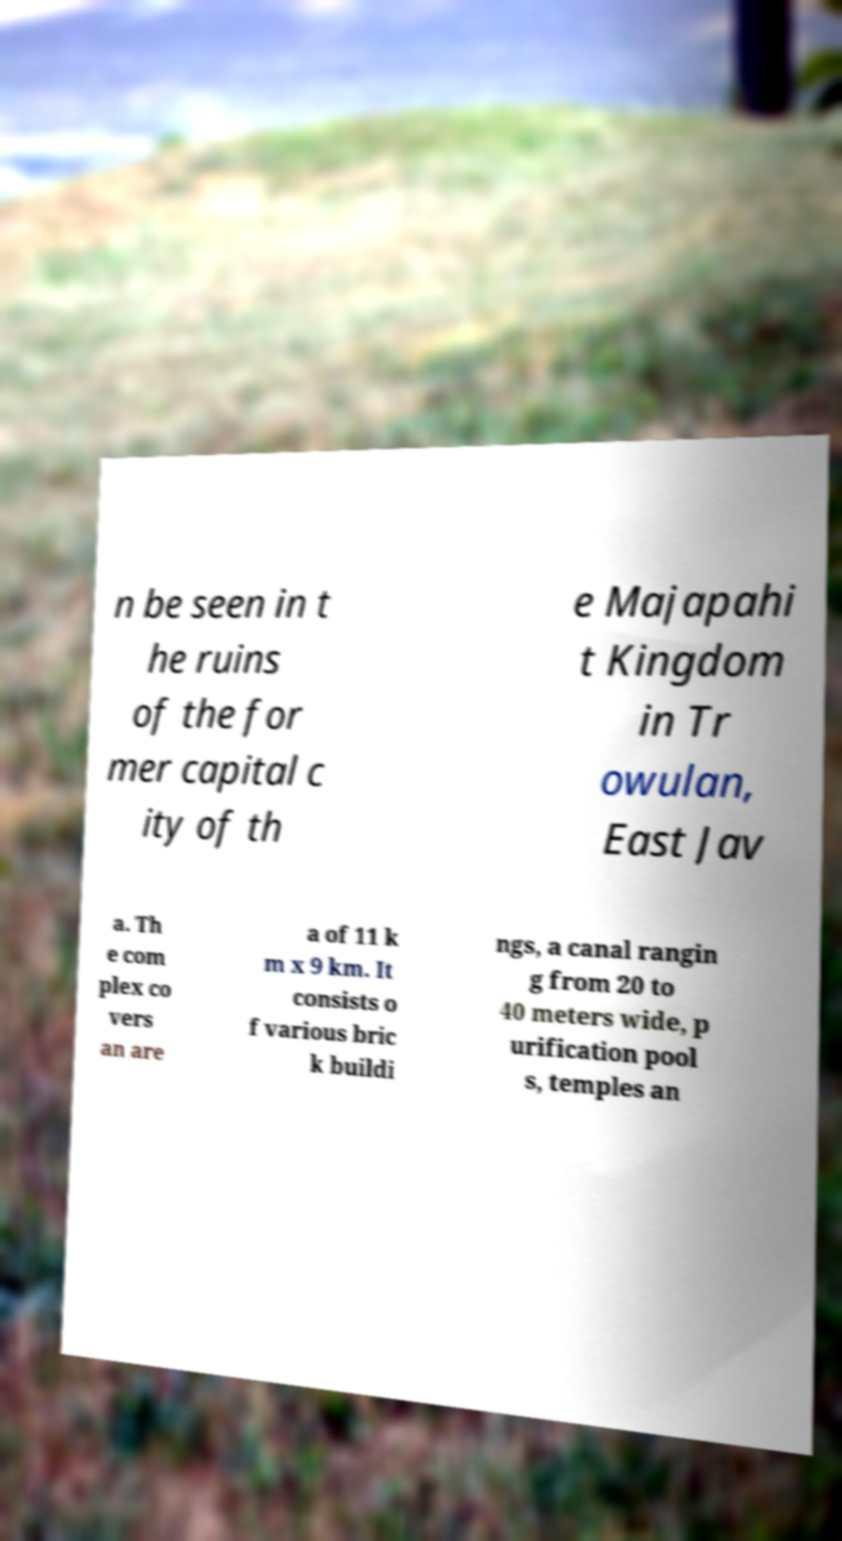Could you extract and type out the text from this image? n be seen in t he ruins of the for mer capital c ity of th e Majapahi t Kingdom in Tr owulan, East Jav a. Th e com plex co vers an are a of 11 k m x 9 km. It consists o f various bric k buildi ngs, a canal rangin g from 20 to 40 meters wide, p urification pool s, temples an 